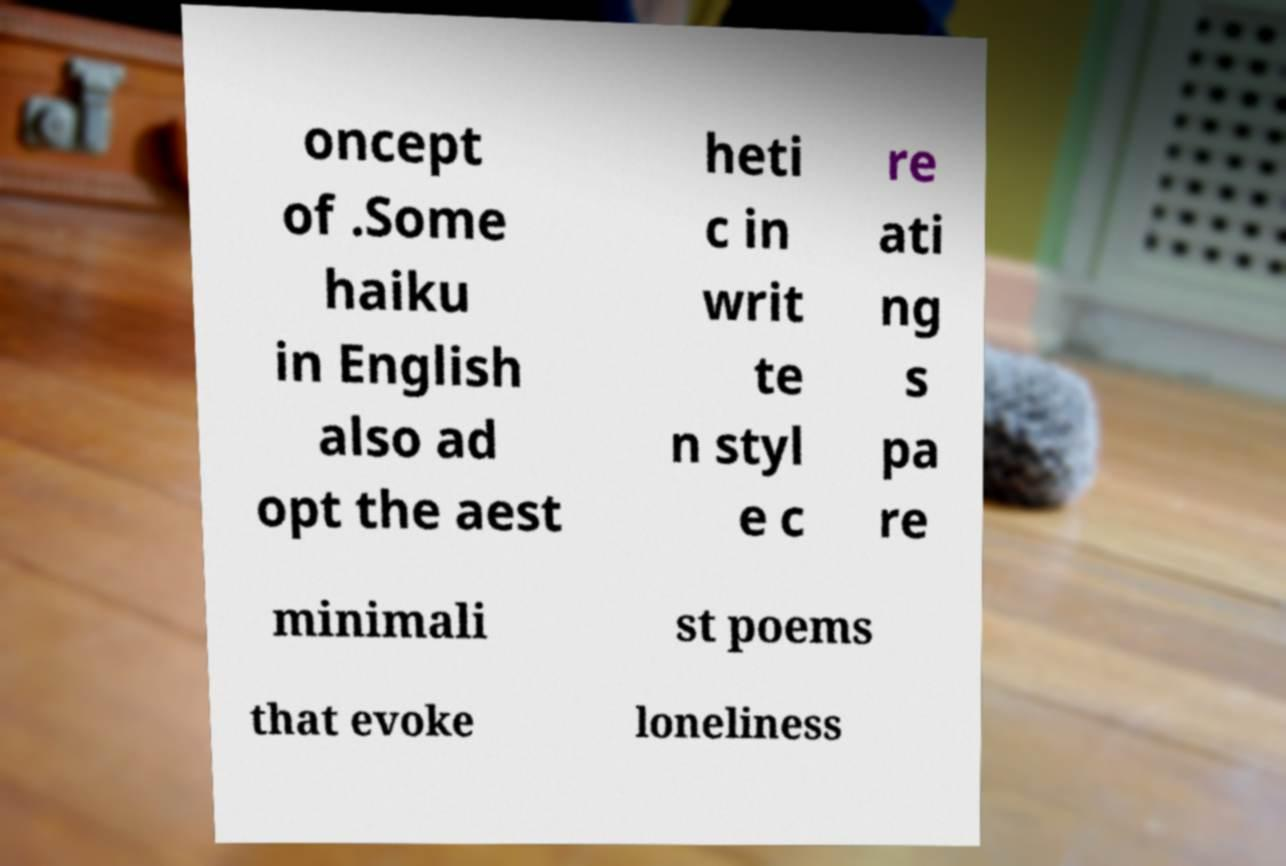Please identify and transcribe the text found in this image. oncept of .Some haiku in English also ad opt the aest heti c in writ te n styl e c re ati ng s pa re minimali st poems that evoke loneliness 